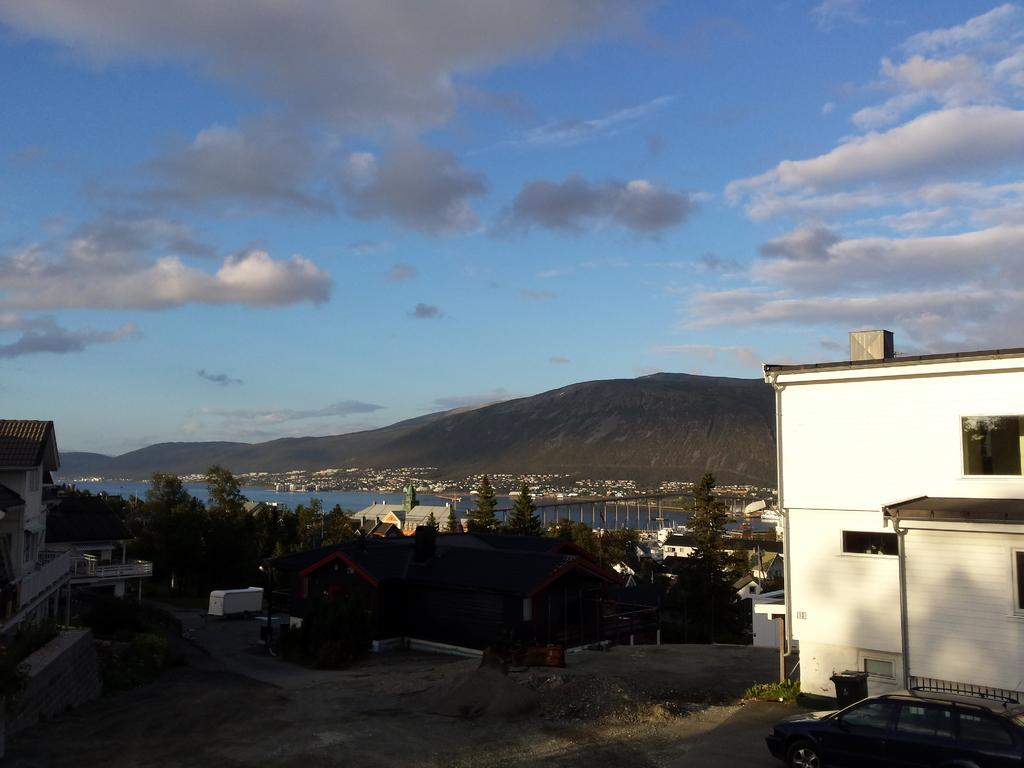What type of structures can be seen in the image? There are buildings in the image. What other natural elements are present in the image? There are trees in the image. What materials can be seen in the image? There are metal rods visible in the image. What can be seen in the background of the image? There is water, hills, and clouds visible in the background of the image. What degree of difficulty is the heart symbolizing in the image? There is: There is no heart symbol or any indication of difficulty levels present in the image. 